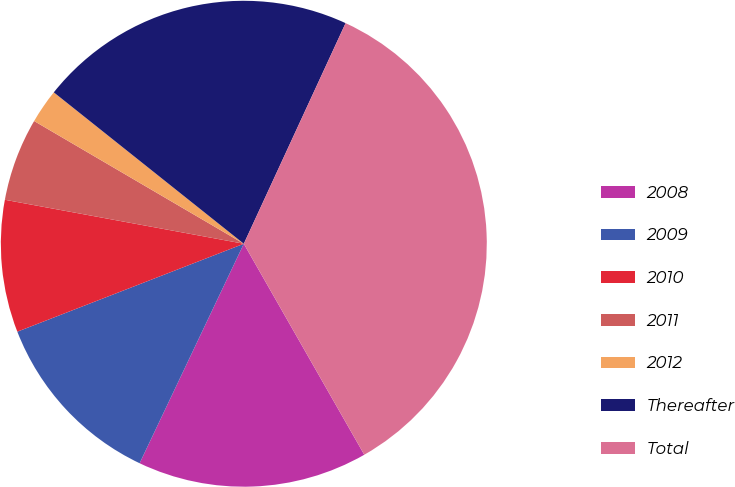Convert chart to OTSL. <chart><loc_0><loc_0><loc_500><loc_500><pie_chart><fcel>2008<fcel>2009<fcel>2010<fcel>2011<fcel>2012<fcel>Thereafter<fcel>Total<nl><fcel>15.31%<fcel>12.05%<fcel>8.79%<fcel>5.53%<fcel>2.28%<fcel>21.17%<fcel>34.86%<nl></chart> 